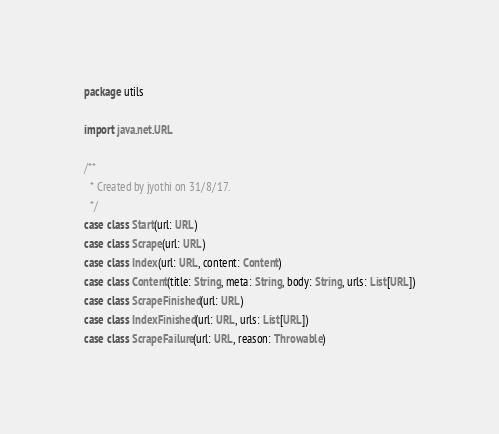<code> <loc_0><loc_0><loc_500><loc_500><_Scala_>package utils

import java.net.URL

/**
  * Created by jyothi on 31/8/17.
  */
case class Start(url: URL)
case class Scrape(url: URL)
case class Index(url: URL, content: Content)
case class Content(title: String, meta: String, body: String, urls: List[URL])
case class ScrapeFinished(url: URL)
case class IndexFinished(url: URL, urls: List[URL])
case class ScrapeFailure(url: URL, reason: Throwable)</code> 